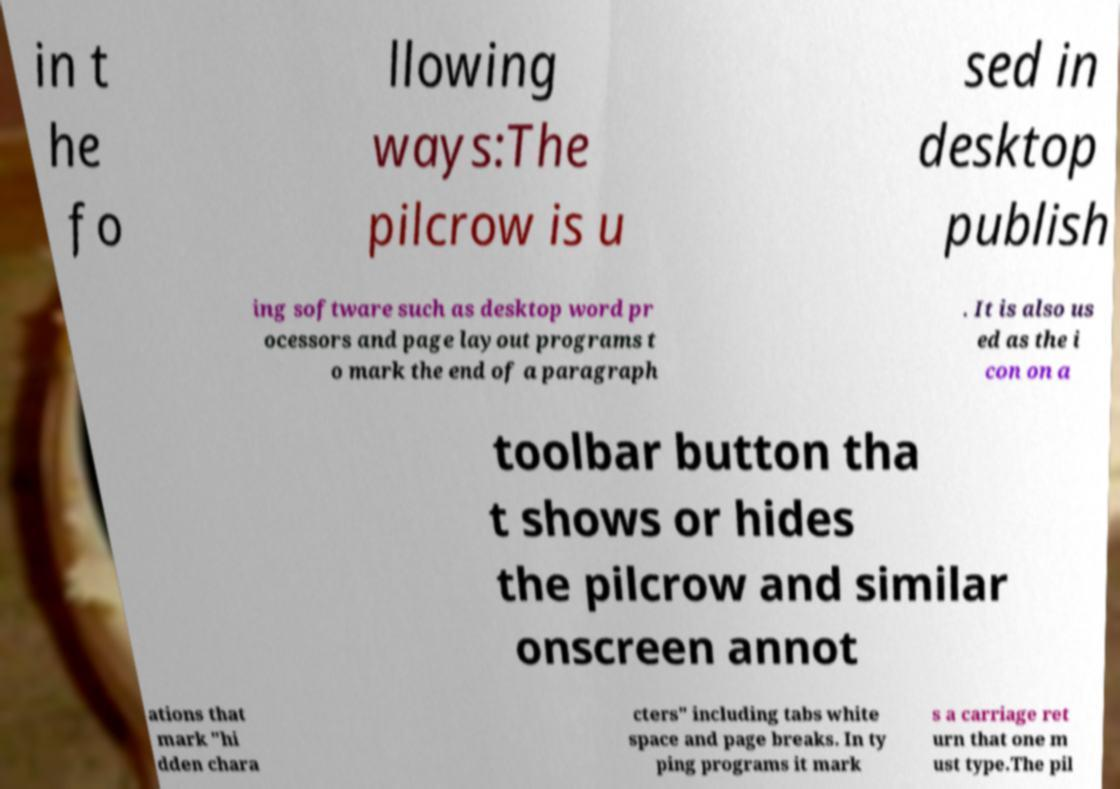Could you extract and type out the text from this image? in t he fo llowing ways:The pilcrow is u sed in desktop publish ing software such as desktop word pr ocessors and page layout programs t o mark the end of a paragraph . It is also us ed as the i con on a toolbar button tha t shows or hides the pilcrow and similar onscreen annot ations that mark "hi dden chara cters" including tabs white space and page breaks. In ty ping programs it mark s a carriage ret urn that one m ust type.The pil 